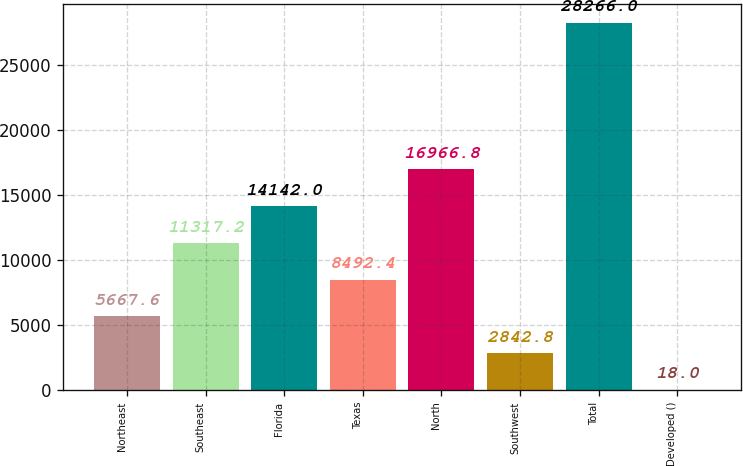<chart> <loc_0><loc_0><loc_500><loc_500><bar_chart><fcel>Northeast<fcel>Southeast<fcel>Florida<fcel>Texas<fcel>North<fcel>Southwest<fcel>Total<fcel>Developed ()<nl><fcel>5667.6<fcel>11317.2<fcel>14142<fcel>8492.4<fcel>16966.8<fcel>2842.8<fcel>28266<fcel>18<nl></chart> 